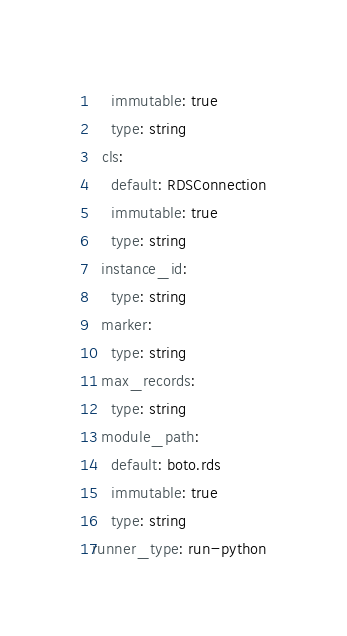Convert code to text. <code><loc_0><loc_0><loc_500><loc_500><_YAML_>    immutable: true
    type: string
  cls:
    default: RDSConnection
    immutable: true
    type: string
  instance_id:
    type: string
  marker:
    type: string
  max_records:
    type: string
  module_path:
    default: boto.rds
    immutable: true
    type: string
runner_type: run-python
</code> 